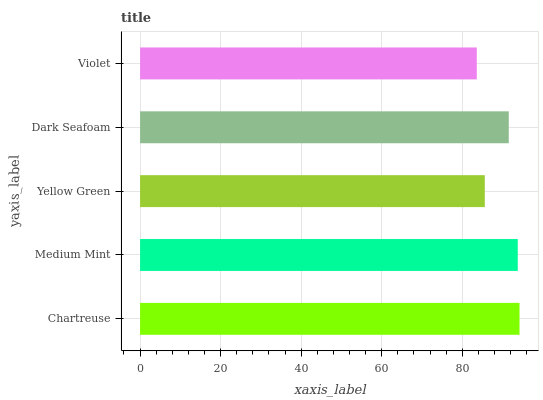Is Violet the minimum?
Answer yes or no. Yes. Is Chartreuse the maximum?
Answer yes or no. Yes. Is Medium Mint the minimum?
Answer yes or no. No. Is Medium Mint the maximum?
Answer yes or no. No. Is Chartreuse greater than Medium Mint?
Answer yes or no. Yes. Is Medium Mint less than Chartreuse?
Answer yes or no. Yes. Is Medium Mint greater than Chartreuse?
Answer yes or no. No. Is Chartreuse less than Medium Mint?
Answer yes or no. No. Is Dark Seafoam the high median?
Answer yes or no. Yes. Is Dark Seafoam the low median?
Answer yes or no. Yes. Is Violet the high median?
Answer yes or no. No. Is Chartreuse the low median?
Answer yes or no. No. 